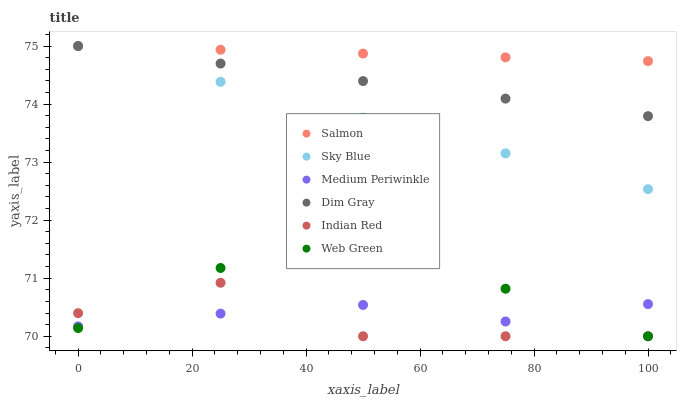Does Indian Red have the minimum area under the curve?
Answer yes or no. Yes. Does Salmon have the maximum area under the curve?
Answer yes or no. Yes. Does Medium Periwinkle have the minimum area under the curve?
Answer yes or no. No. Does Medium Periwinkle have the maximum area under the curve?
Answer yes or no. No. Is Dim Gray the smoothest?
Answer yes or no. Yes. Is Indian Red the roughest?
Answer yes or no. Yes. Is Medium Periwinkle the smoothest?
Answer yes or no. No. Is Medium Periwinkle the roughest?
Answer yes or no. No. Does Web Green have the lowest value?
Answer yes or no. Yes. Does Medium Periwinkle have the lowest value?
Answer yes or no. No. Does Sky Blue have the highest value?
Answer yes or no. Yes. Does Medium Periwinkle have the highest value?
Answer yes or no. No. Is Indian Red less than Dim Gray?
Answer yes or no. Yes. Is Salmon greater than Indian Red?
Answer yes or no. Yes. Does Sky Blue intersect Salmon?
Answer yes or no. Yes. Is Sky Blue less than Salmon?
Answer yes or no. No. Is Sky Blue greater than Salmon?
Answer yes or no. No. Does Indian Red intersect Dim Gray?
Answer yes or no. No. 